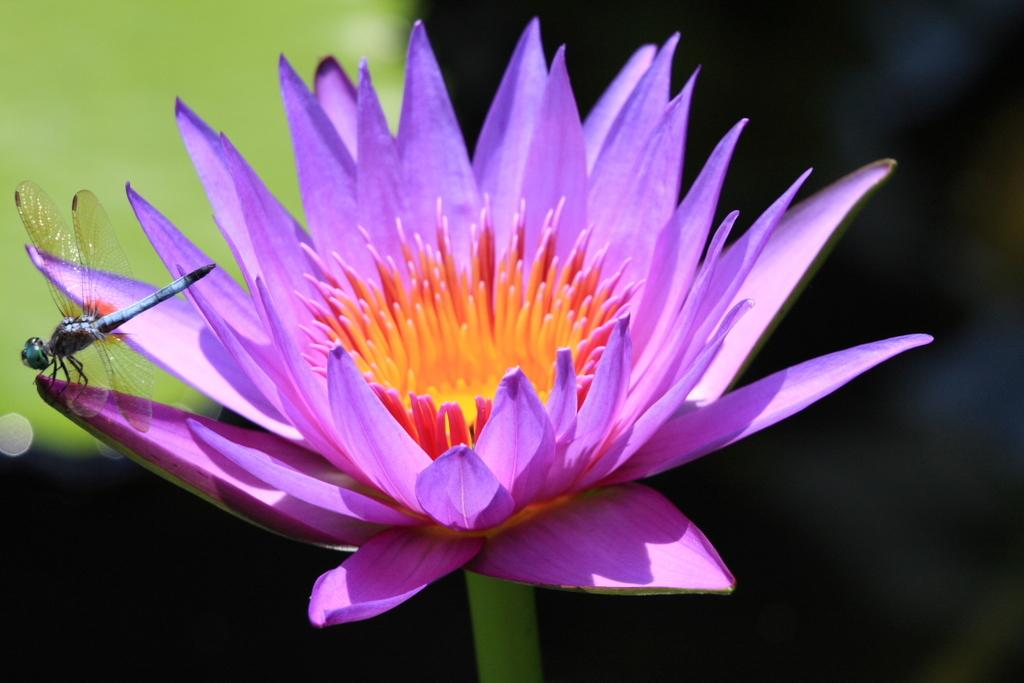What type of flower is in the image? There is a purple color flower in the image. Is there anything on the flower? Yes, an insect is on the flower. What colors can be seen in the background of the image? The background of the image is green and black. How many sisters does the insect have in the image? There is no information about the insect's family in the image, so we cannot determine the number of sisters it has. 